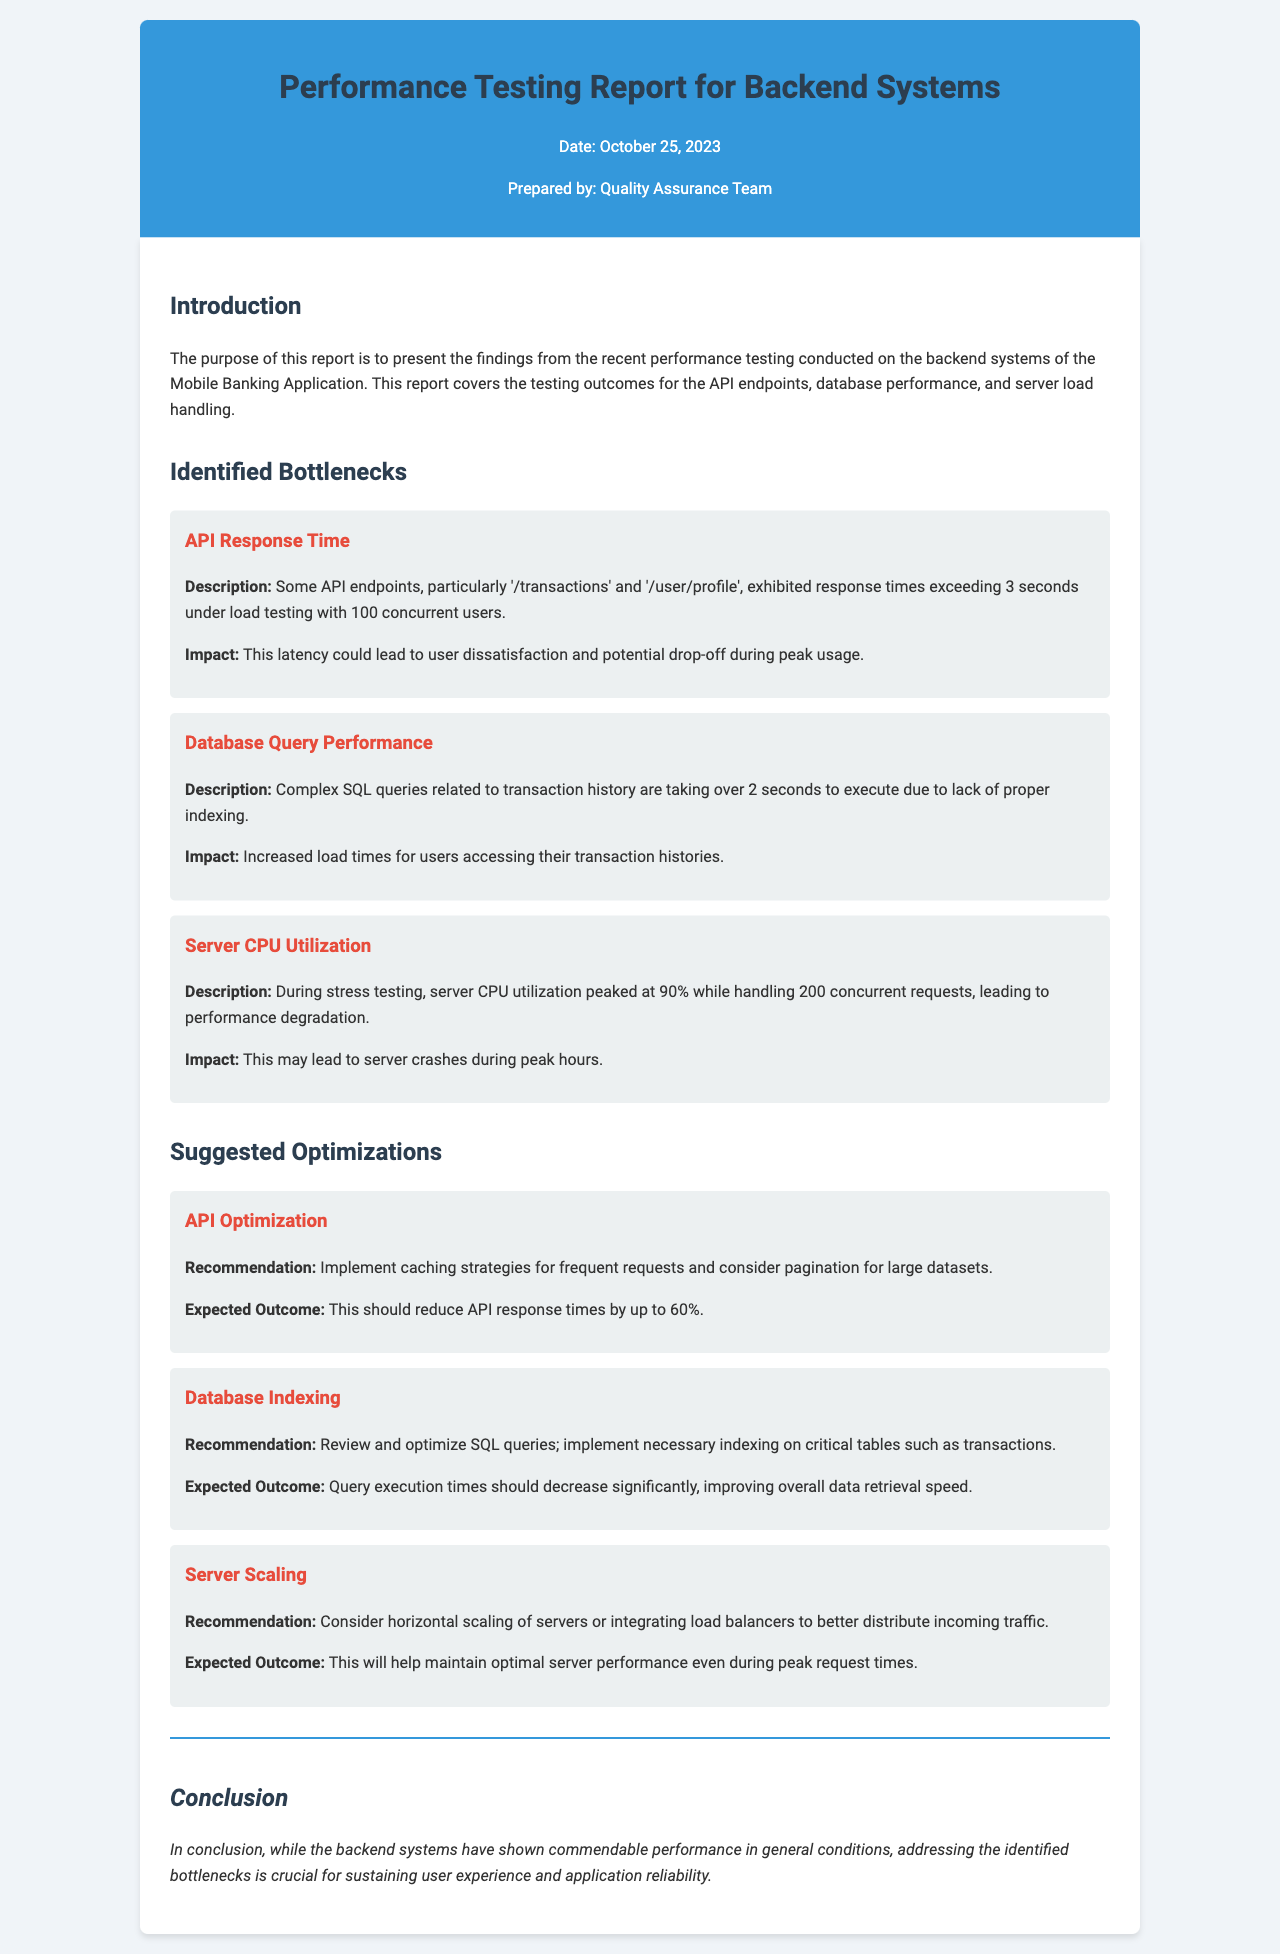What is the date of the performance testing report? The date of the report is explicitly mentioned in the header section.
Answer: October 25, 2023 Who prepared the performance testing report? The document states that the report was prepared by the Quality Assurance Team.
Answer: Quality Assurance Team Which API endpoints showed latency during the testing? The document identifies specific API endpoints that experienced latency issues.
Answer: '/transactions' and '/user/profile' What is the expected outcome of implementing caching strategies? The expected outcome of the recommendation is provided in the suggested optimizations section.
Answer: Reduce API response times by up to 60% What issue caused server CPU utilization to peak at 90%? The document describes the testing condition that led to high CPU utilization.
Answer: Handling 200 concurrent requests What is recommended to improve database query performance? The document provides a specific recommendation to enhance database performance within the suggested optimizations.
Answer: Implement necessary indexing on critical tables such as transactions What is the impact of the identified API response time latency? The document states the consequences of the latency issue for user experience.
Answer: User dissatisfaction and potential drop-off during peak usage What is the overall conclusion about the backend systems? The conclusion summarizes the performance status and needs addressed in the document.
Answer: Addressing the identified bottlenecks is crucial for sustaining user experience and application reliability 